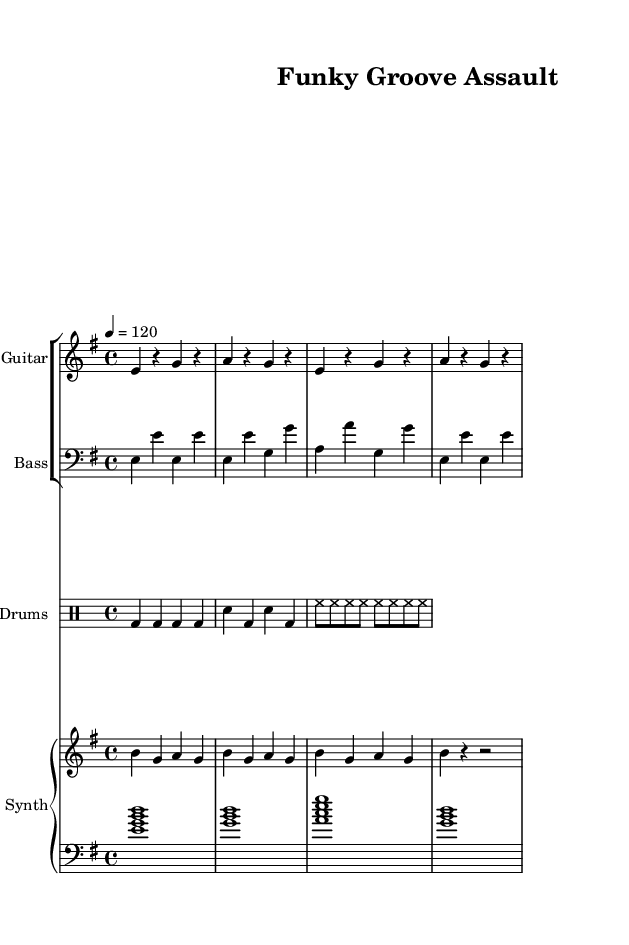What is the key signature of this music? The key signature is E minor, which has one sharp (F#). The key is indicated at the beginning of the score after the clef and before the time signature.
Answer: E minor What is the time signature of this music? The time signature is 4/4, which means there are four beats in each measure and the quarter note gets one beat. This can be found next to the key signature at the start of the score.
Answer: 4/4 What is the tempo marking of this piece? The tempo marking is 120 beats per minute, indicated above the staff at the beginning of the score. The tempo refers to how fast the piece is to be played.
Answer: 120 How many measures are in the guitar riff? The guitar riff consists of 8 measures. Each measure is divided by vertical lines on the staff, and by counting the segments, we can see there are 8 in total.
Answer: 8 What is the primary characteristic of the bass line? The bass line features funk-inspired rhythms with syncopation, which is evident in the rhythmic placement of the notes against the beat. This creates a groove-oriented feel typical in groove metal.
Answer: Funk-inspired syncopation How does the drum pattern contribute to the groove of the piece? The drum pattern uses a steady kick drum on each beat, combined with snare hits and consistent hi-hat eighth notes, creating a driving rhythmic foundation essential for groove metal styles. This layering emphasizes the groove and complements the other instruments.
Answer: Driving rhythmic foundation What is the role of the synth chords in this composition? The synth chords provide harmonic support and contribute to the overall atmosphere of the track. They are played throughout and create a backdrop for the melodic lines, enhancing the groove metal sound with rich textures.
Answer: Harmonic support 